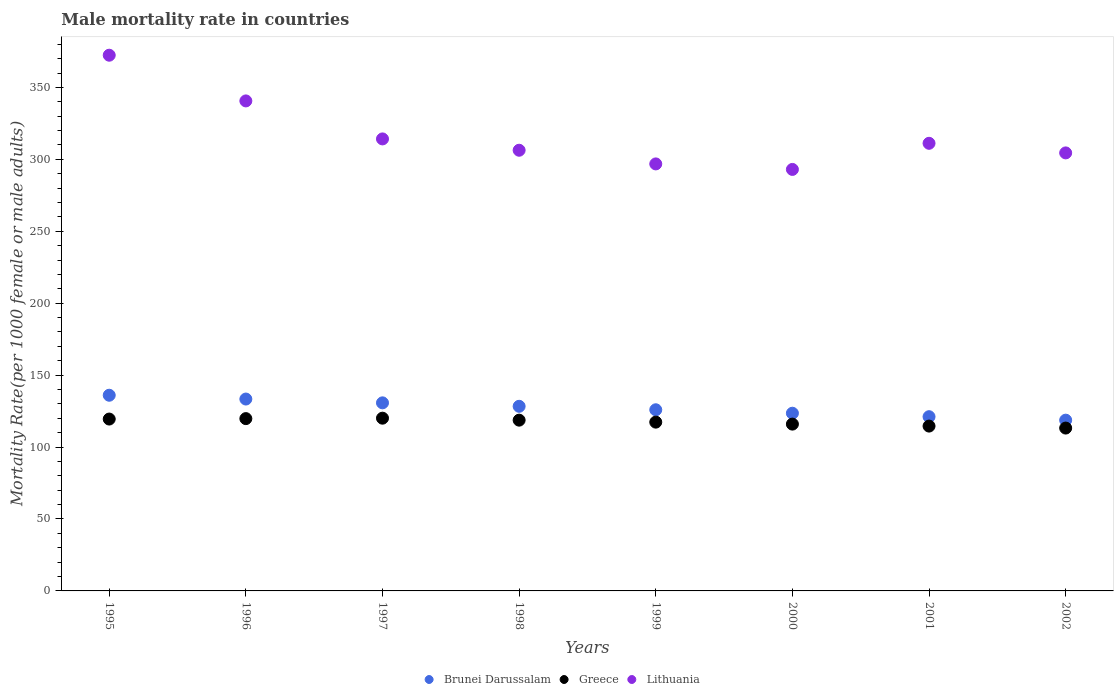What is the male mortality rate in Greece in 2000?
Your answer should be very brief. 115.96. Across all years, what is the maximum male mortality rate in Greece?
Offer a terse response. 120.08. Across all years, what is the minimum male mortality rate in Brunei Darussalam?
Your response must be concise. 118.7. In which year was the male mortality rate in Lithuania maximum?
Offer a terse response. 1995. In which year was the male mortality rate in Lithuania minimum?
Ensure brevity in your answer.  2000. What is the total male mortality rate in Greece in the graph?
Make the answer very short. 939.11. What is the difference between the male mortality rate in Greece in 1995 and that in 1996?
Give a very brief answer. -0.3. What is the difference between the male mortality rate in Greece in 1999 and the male mortality rate in Lithuania in 2001?
Provide a short and direct response. -193.83. What is the average male mortality rate in Lithuania per year?
Your answer should be compact. 317.37. In the year 1995, what is the difference between the male mortality rate in Greece and male mortality rate in Lithuania?
Offer a terse response. -252.91. In how many years, is the male mortality rate in Lithuania greater than 290?
Make the answer very short. 8. What is the ratio of the male mortality rate in Lithuania in 1997 to that in 2001?
Offer a terse response. 1.01. What is the difference between the highest and the second highest male mortality rate in Brunei Darussalam?
Provide a short and direct response. 2.64. What is the difference between the highest and the lowest male mortality rate in Brunei Darussalam?
Your answer should be compact. 17.32. In how many years, is the male mortality rate in Greece greater than the average male mortality rate in Greece taken over all years?
Provide a short and direct response. 4. Is the sum of the male mortality rate in Greece in 1998 and 2002 greater than the maximum male mortality rate in Lithuania across all years?
Provide a short and direct response. No. Is it the case that in every year, the sum of the male mortality rate in Brunei Darussalam and male mortality rate in Lithuania  is greater than the male mortality rate in Greece?
Your answer should be compact. Yes. Does the male mortality rate in Lithuania monotonically increase over the years?
Your response must be concise. No. Is the male mortality rate in Lithuania strictly less than the male mortality rate in Brunei Darussalam over the years?
Ensure brevity in your answer.  No. How many dotlines are there?
Offer a very short reply. 3. How many years are there in the graph?
Offer a terse response. 8. Are the values on the major ticks of Y-axis written in scientific E-notation?
Ensure brevity in your answer.  No. Does the graph contain grids?
Offer a very short reply. No. Where does the legend appear in the graph?
Your answer should be very brief. Bottom center. How many legend labels are there?
Offer a very short reply. 3. What is the title of the graph?
Provide a succinct answer. Male mortality rate in countries. Does "Latin America(all income levels)" appear as one of the legend labels in the graph?
Your answer should be compact. No. What is the label or title of the X-axis?
Offer a terse response. Years. What is the label or title of the Y-axis?
Offer a very short reply. Mortality Rate(per 1000 female or male adults). What is the Mortality Rate(per 1000 female or male adults) of Brunei Darussalam in 1995?
Ensure brevity in your answer.  136.02. What is the Mortality Rate(per 1000 female or male adults) of Greece in 1995?
Provide a succinct answer. 119.47. What is the Mortality Rate(per 1000 female or male adults) of Lithuania in 1995?
Provide a succinct answer. 372.39. What is the Mortality Rate(per 1000 female or male adults) of Brunei Darussalam in 1996?
Offer a terse response. 133.38. What is the Mortality Rate(per 1000 female or male adults) of Greece in 1996?
Ensure brevity in your answer.  119.78. What is the Mortality Rate(per 1000 female or male adults) in Lithuania in 1996?
Provide a short and direct response. 340.62. What is the Mortality Rate(per 1000 female or male adults) in Brunei Darussalam in 1997?
Provide a short and direct response. 130.74. What is the Mortality Rate(per 1000 female or male adults) in Greece in 1997?
Make the answer very short. 120.08. What is the Mortality Rate(per 1000 female or male adults) of Lithuania in 1997?
Your answer should be very brief. 314.2. What is the Mortality Rate(per 1000 female or male adults) of Brunei Darussalam in 1998?
Make the answer very short. 128.33. What is the Mortality Rate(per 1000 female or male adults) of Greece in 1998?
Provide a short and direct response. 118.71. What is the Mortality Rate(per 1000 female or male adults) in Lithuania in 1998?
Offer a very short reply. 306.33. What is the Mortality Rate(per 1000 female or male adults) in Brunei Darussalam in 1999?
Offer a very short reply. 125.92. What is the Mortality Rate(per 1000 female or male adults) of Greece in 1999?
Your response must be concise. 117.33. What is the Mortality Rate(per 1000 female or male adults) in Lithuania in 1999?
Offer a very short reply. 296.83. What is the Mortality Rate(per 1000 female or male adults) of Brunei Darussalam in 2000?
Offer a very short reply. 123.52. What is the Mortality Rate(per 1000 female or male adults) of Greece in 2000?
Give a very brief answer. 115.96. What is the Mortality Rate(per 1000 female or male adults) of Lithuania in 2000?
Give a very brief answer. 293. What is the Mortality Rate(per 1000 female or male adults) in Brunei Darussalam in 2001?
Provide a short and direct response. 121.11. What is the Mortality Rate(per 1000 female or male adults) of Greece in 2001?
Offer a very short reply. 114.58. What is the Mortality Rate(per 1000 female or male adults) in Lithuania in 2001?
Make the answer very short. 311.16. What is the Mortality Rate(per 1000 female or male adults) in Brunei Darussalam in 2002?
Provide a succinct answer. 118.7. What is the Mortality Rate(per 1000 female or male adults) of Greece in 2002?
Give a very brief answer. 113.2. What is the Mortality Rate(per 1000 female or male adults) in Lithuania in 2002?
Your answer should be very brief. 304.48. Across all years, what is the maximum Mortality Rate(per 1000 female or male adults) in Brunei Darussalam?
Make the answer very short. 136.02. Across all years, what is the maximum Mortality Rate(per 1000 female or male adults) of Greece?
Your answer should be compact. 120.08. Across all years, what is the maximum Mortality Rate(per 1000 female or male adults) of Lithuania?
Your answer should be compact. 372.39. Across all years, what is the minimum Mortality Rate(per 1000 female or male adults) of Brunei Darussalam?
Keep it short and to the point. 118.7. Across all years, what is the minimum Mortality Rate(per 1000 female or male adults) of Greece?
Keep it short and to the point. 113.2. Across all years, what is the minimum Mortality Rate(per 1000 female or male adults) in Lithuania?
Provide a short and direct response. 293. What is the total Mortality Rate(per 1000 female or male adults) in Brunei Darussalam in the graph?
Your answer should be very brief. 1017.73. What is the total Mortality Rate(per 1000 female or male adults) of Greece in the graph?
Your answer should be compact. 939.11. What is the total Mortality Rate(per 1000 female or male adults) in Lithuania in the graph?
Provide a succinct answer. 2539. What is the difference between the Mortality Rate(per 1000 female or male adults) of Brunei Darussalam in 1995 and that in 1996?
Provide a short and direct response. 2.64. What is the difference between the Mortality Rate(per 1000 female or male adults) in Greece in 1995 and that in 1996?
Offer a very short reply. -0.3. What is the difference between the Mortality Rate(per 1000 female or male adults) in Lithuania in 1995 and that in 1996?
Ensure brevity in your answer.  31.77. What is the difference between the Mortality Rate(per 1000 female or male adults) in Brunei Darussalam in 1995 and that in 1997?
Offer a very short reply. 5.28. What is the difference between the Mortality Rate(per 1000 female or male adults) in Greece in 1995 and that in 1997?
Provide a succinct answer. -0.61. What is the difference between the Mortality Rate(per 1000 female or male adults) of Lithuania in 1995 and that in 1997?
Your response must be concise. 58.18. What is the difference between the Mortality Rate(per 1000 female or male adults) of Brunei Darussalam in 1995 and that in 1998?
Ensure brevity in your answer.  7.69. What is the difference between the Mortality Rate(per 1000 female or male adults) of Greece in 1995 and that in 1998?
Your answer should be compact. 0.77. What is the difference between the Mortality Rate(per 1000 female or male adults) of Lithuania in 1995 and that in 1998?
Offer a very short reply. 66.06. What is the difference between the Mortality Rate(per 1000 female or male adults) of Brunei Darussalam in 1995 and that in 1999?
Offer a very short reply. 10.1. What is the difference between the Mortality Rate(per 1000 female or male adults) in Greece in 1995 and that in 1999?
Give a very brief answer. 2.14. What is the difference between the Mortality Rate(per 1000 female or male adults) in Lithuania in 1995 and that in 1999?
Ensure brevity in your answer.  75.56. What is the difference between the Mortality Rate(per 1000 female or male adults) of Brunei Darussalam in 1995 and that in 2000?
Your response must be concise. 12.5. What is the difference between the Mortality Rate(per 1000 female or male adults) in Greece in 1995 and that in 2000?
Offer a very short reply. 3.52. What is the difference between the Mortality Rate(per 1000 female or male adults) of Lithuania in 1995 and that in 2000?
Provide a short and direct response. 79.39. What is the difference between the Mortality Rate(per 1000 female or male adults) of Brunei Darussalam in 1995 and that in 2001?
Ensure brevity in your answer.  14.91. What is the difference between the Mortality Rate(per 1000 female or male adults) of Greece in 1995 and that in 2001?
Offer a very short reply. 4.89. What is the difference between the Mortality Rate(per 1000 female or male adults) of Lithuania in 1995 and that in 2001?
Ensure brevity in your answer.  61.23. What is the difference between the Mortality Rate(per 1000 female or male adults) of Brunei Darussalam in 1995 and that in 2002?
Ensure brevity in your answer.  17.32. What is the difference between the Mortality Rate(per 1000 female or male adults) in Greece in 1995 and that in 2002?
Make the answer very short. 6.27. What is the difference between the Mortality Rate(per 1000 female or male adults) in Lithuania in 1995 and that in 2002?
Your response must be concise. 67.91. What is the difference between the Mortality Rate(per 1000 female or male adults) of Brunei Darussalam in 1996 and that in 1997?
Keep it short and to the point. 2.64. What is the difference between the Mortality Rate(per 1000 female or male adults) in Greece in 1996 and that in 1997?
Provide a short and direct response. -0.3. What is the difference between the Mortality Rate(per 1000 female or male adults) of Lithuania in 1996 and that in 1997?
Give a very brief answer. 26.41. What is the difference between the Mortality Rate(per 1000 female or male adults) of Brunei Darussalam in 1996 and that in 1998?
Provide a short and direct response. 5.05. What is the difference between the Mortality Rate(per 1000 female or male adults) in Greece in 1996 and that in 1998?
Ensure brevity in your answer.  1.07. What is the difference between the Mortality Rate(per 1000 female or male adults) in Lithuania in 1996 and that in 1998?
Your answer should be compact. 34.29. What is the difference between the Mortality Rate(per 1000 female or male adults) in Brunei Darussalam in 1996 and that in 1999?
Keep it short and to the point. 7.46. What is the difference between the Mortality Rate(per 1000 female or male adults) in Greece in 1996 and that in 1999?
Offer a terse response. 2.45. What is the difference between the Mortality Rate(per 1000 female or male adults) in Lithuania in 1996 and that in 1999?
Offer a terse response. 43.79. What is the difference between the Mortality Rate(per 1000 female or male adults) of Brunei Darussalam in 1996 and that in 2000?
Ensure brevity in your answer.  9.86. What is the difference between the Mortality Rate(per 1000 female or male adults) in Greece in 1996 and that in 2000?
Your answer should be compact. 3.82. What is the difference between the Mortality Rate(per 1000 female or male adults) of Lithuania in 1996 and that in 2000?
Offer a terse response. 47.62. What is the difference between the Mortality Rate(per 1000 female or male adults) in Brunei Darussalam in 1996 and that in 2001?
Your answer should be compact. 12.27. What is the difference between the Mortality Rate(per 1000 female or male adults) in Greece in 1996 and that in 2001?
Offer a terse response. 5.2. What is the difference between the Mortality Rate(per 1000 female or male adults) of Lithuania in 1996 and that in 2001?
Keep it short and to the point. 29.46. What is the difference between the Mortality Rate(per 1000 female or male adults) of Brunei Darussalam in 1996 and that in 2002?
Provide a succinct answer. 14.68. What is the difference between the Mortality Rate(per 1000 female or male adults) of Greece in 1996 and that in 2002?
Your answer should be very brief. 6.57. What is the difference between the Mortality Rate(per 1000 female or male adults) in Lithuania in 1996 and that in 2002?
Your response must be concise. 36.14. What is the difference between the Mortality Rate(per 1000 female or male adults) in Brunei Darussalam in 1997 and that in 1998?
Your answer should be compact. 2.41. What is the difference between the Mortality Rate(per 1000 female or male adults) of Greece in 1997 and that in 1998?
Ensure brevity in your answer.  1.38. What is the difference between the Mortality Rate(per 1000 female or male adults) in Lithuania in 1997 and that in 1998?
Offer a terse response. 7.88. What is the difference between the Mortality Rate(per 1000 female or male adults) in Brunei Darussalam in 1997 and that in 1999?
Give a very brief answer. 4.81. What is the difference between the Mortality Rate(per 1000 female or male adults) in Greece in 1997 and that in 1999?
Your response must be concise. 2.75. What is the difference between the Mortality Rate(per 1000 female or male adults) in Lithuania in 1997 and that in 1999?
Ensure brevity in your answer.  17.38. What is the difference between the Mortality Rate(per 1000 female or male adults) in Brunei Darussalam in 1997 and that in 2000?
Give a very brief answer. 7.22. What is the difference between the Mortality Rate(per 1000 female or male adults) of Greece in 1997 and that in 2000?
Your answer should be compact. 4.13. What is the difference between the Mortality Rate(per 1000 female or male adults) in Lithuania in 1997 and that in 2000?
Your response must be concise. 21.21. What is the difference between the Mortality Rate(per 1000 female or male adults) of Brunei Darussalam in 1997 and that in 2001?
Ensure brevity in your answer.  9.63. What is the difference between the Mortality Rate(per 1000 female or male adults) in Greece in 1997 and that in 2001?
Provide a short and direct response. 5.5. What is the difference between the Mortality Rate(per 1000 female or male adults) of Lithuania in 1997 and that in 2001?
Provide a short and direct response. 3.05. What is the difference between the Mortality Rate(per 1000 female or male adults) in Brunei Darussalam in 1997 and that in 2002?
Keep it short and to the point. 12.03. What is the difference between the Mortality Rate(per 1000 female or male adults) of Greece in 1997 and that in 2002?
Provide a succinct answer. 6.88. What is the difference between the Mortality Rate(per 1000 female or male adults) of Lithuania in 1997 and that in 2002?
Your answer should be very brief. 9.72. What is the difference between the Mortality Rate(per 1000 female or male adults) of Brunei Darussalam in 1998 and that in 1999?
Ensure brevity in your answer.  2.41. What is the difference between the Mortality Rate(per 1000 female or male adults) in Greece in 1998 and that in 1999?
Provide a succinct answer. 1.38. What is the difference between the Mortality Rate(per 1000 female or male adults) in Lithuania in 1998 and that in 1999?
Offer a terse response. 9.5. What is the difference between the Mortality Rate(per 1000 female or male adults) in Brunei Darussalam in 1998 and that in 2000?
Your answer should be compact. 4.81. What is the difference between the Mortality Rate(per 1000 female or male adults) in Greece in 1998 and that in 2000?
Your answer should be compact. 2.75. What is the difference between the Mortality Rate(per 1000 female or male adults) of Lithuania in 1998 and that in 2000?
Provide a short and direct response. 13.33. What is the difference between the Mortality Rate(per 1000 female or male adults) in Brunei Darussalam in 1998 and that in 2001?
Ensure brevity in your answer.  7.22. What is the difference between the Mortality Rate(per 1000 female or male adults) of Greece in 1998 and that in 2001?
Your answer should be compact. 4.13. What is the difference between the Mortality Rate(per 1000 female or male adults) in Lithuania in 1998 and that in 2001?
Give a very brief answer. -4.83. What is the difference between the Mortality Rate(per 1000 female or male adults) in Brunei Darussalam in 1998 and that in 2002?
Keep it short and to the point. 9.63. What is the difference between the Mortality Rate(per 1000 female or male adults) of Greece in 1998 and that in 2002?
Give a very brief answer. 5.5. What is the difference between the Mortality Rate(per 1000 female or male adults) in Lithuania in 1998 and that in 2002?
Offer a very short reply. 1.85. What is the difference between the Mortality Rate(per 1000 female or male adults) of Brunei Darussalam in 1999 and that in 2000?
Keep it short and to the point. 2.41. What is the difference between the Mortality Rate(per 1000 female or male adults) of Greece in 1999 and that in 2000?
Ensure brevity in your answer.  1.38. What is the difference between the Mortality Rate(per 1000 female or male adults) in Lithuania in 1999 and that in 2000?
Your answer should be compact. 3.83. What is the difference between the Mortality Rate(per 1000 female or male adults) of Brunei Darussalam in 1999 and that in 2001?
Your answer should be very brief. 4.81. What is the difference between the Mortality Rate(per 1000 female or male adults) of Greece in 1999 and that in 2001?
Ensure brevity in your answer.  2.75. What is the difference between the Mortality Rate(per 1000 female or male adults) in Lithuania in 1999 and that in 2001?
Provide a succinct answer. -14.33. What is the difference between the Mortality Rate(per 1000 female or male adults) in Brunei Darussalam in 1999 and that in 2002?
Give a very brief answer. 7.22. What is the difference between the Mortality Rate(per 1000 female or male adults) of Greece in 1999 and that in 2002?
Your response must be concise. 4.13. What is the difference between the Mortality Rate(per 1000 female or male adults) of Lithuania in 1999 and that in 2002?
Give a very brief answer. -7.66. What is the difference between the Mortality Rate(per 1000 female or male adults) in Brunei Darussalam in 2000 and that in 2001?
Your answer should be compact. 2.41. What is the difference between the Mortality Rate(per 1000 female or male adults) in Greece in 2000 and that in 2001?
Provide a succinct answer. 1.38. What is the difference between the Mortality Rate(per 1000 female or male adults) in Lithuania in 2000 and that in 2001?
Your response must be concise. -18.16. What is the difference between the Mortality Rate(per 1000 female or male adults) of Brunei Darussalam in 2000 and that in 2002?
Provide a short and direct response. 4.81. What is the difference between the Mortality Rate(per 1000 female or male adults) of Greece in 2000 and that in 2002?
Give a very brief answer. 2.75. What is the difference between the Mortality Rate(per 1000 female or male adults) of Lithuania in 2000 and that in 2002?
Provide a short and direct response. -11.48. What is the difference between the Mortality Rate(per 1000 female or male adults) of Brunei Darussalam in 2001 and that in 2002?
Provide a succinct answer. 2.41. What is the difference between the Mortality Rate(per 1000 female or male adults) of Greece in 2001 and that in 2002?
Offer a very short reply. 1.38. What is the difference between the Mortality Rate(per 1000 female or male adults) of Lithuania in 2001 and that in 2002?
Your answer should be compact. 6.67. What is the difference between the Mortality Rate(per 1000 female or male adults) in Brunei Darussalam in 1995 and the Mortality Rate(per 1000 female or male adults) in Greece in 1996?
Offer a terse response. 16.24. What is the difference between the Mortality Rate(per 1000 female or male adults) of Brunei Darussalam in 1995 and the Mortality Rate(per 1000 female or male adults) of Lithuania in 1996?
Provide a short and direct response. -204.6. What is the difference between the Mortality Rate(per 1000 female or male adults) of Greece in 1995 and the Mortality Rate(per 1000 female or male adults) of Lithuania in 1996?
Give a very brief answer. -221.15. What is the difference between the Mortality Rate(per 1000 female or male adults) of Brunei Darussalam in 1995 and the Mortality Rate(per 1000 female or male adults) of Greece in 1997?
Make the answer very short. 15.94. What is the difference between the Mortality Rate(per 1000 female or male adults) in Brunei Darussalam in 1995 and the Mortality Rate(per 1000 female or male adults) in Lithuania in 1997?
Keep it short and to the point. -178.18. What is the difference between the Mortality Rate(per 1000 female or male adults) of Greece in 1995 and the Mortality Rate(per 1000 female or male adults) of Lithuania in 1997?
Offer a very short reply. -194.73. What is the difference between the Mortality Rate(per 1000 female or male adults) of Brunei Darussalam in 1995 and the Mortality Rate(per 1000 female or male adults) of Greece in 1998?
Offer a very short reply. 17.32. What is the difference between the Mortality Rate(per 1000 female or male adults) in Brunei Darussalam in 1995 and the Mortality Rate(per 1000 female or male adults) in Lithuania in 1998?
Your answer should be compact. -170.31. What is the difference between the Mortality Rate(per 1000 female or male adults) of Greece in 1995 and the Mortality Rate(per 1000 female or male adults) of Lithuania in 1998?
Your answer should be compact. -186.86. What is the difference between the Mortality Rate(per 1000 female or male adults) of Brunei Darussalam in 1995 and the Mortality Rate(per 1000 female or male adults) of Greece in 1999?
Provide a succinct answer. 18.69. What is the difference between the Mortality Rate(per 1000 female or male adults) in Brunei Darussalam in 1995 and the Mortality Rate(per 1000 female or male adults) in Lithuania in 1999?
Keep it short and to the point. -160.81. What is the difference between the Mortality Rate(per 1000 female or male adults) in Greece in 1995 and the Mortality Rate(per 1000 female or male adults) in Lithuania in 1999?
Offer a very short reply. -177.35. What is the difference between the Mortality Rate(per 1000 female or male adults) in Brunei Darussalam in 1995 and the Mortality Rate(per 1000 female or male adults) in Greece in 2000?
Provide a succinct answer. 20.07. What is the difference between the Mortality Rate(per 1000 female or male adults) in Brunei Darussalam in 1995 and the Mortality Rate(per 1000 female or male adults) in Lithuania in 2000?
Ensure brevity in your answer.  -156.98. What is the difference between the Mortality Rate(per 1000 female or male adults) in Greece in 1995 and the Mortality Rate(per 1000 female or male adults) in Lithuania in 2000?
Give a very brief answer. -173.53. What is the difference between the Mortality Rate(per 1000 female or male adults) of Brunei Darussalam in 1995 and the Mortality Rate(per 1000 female or male adults) of Greece in 2001?
Keep it short and to the point. 21.44. What is the difference between the Mortality Rate(per 1000 female or male adults) in Brunei Darussalam in 1995 and the Mortality Rate(per 1000 female or male adults) in Lithuania in 2001?
Your answer should be compact. -175.13. What is the difference between the Mortality Rate(per 1000 female or male adults) of Greece in 1995 and the Mortality Rate(per 1000 female or male adults) of Lithuania in 2001?
Offer a terse response. -191.68. What is the difference between the Mortality Rate(per 1000 female or male adults) in Brunei Darussalam in 1995 and the Mortality Rate(per 1000 female or male adults) in Greece in 2002?
Your answer should be very brief. 22.82. What is the difference between the Mortality Rate(per 1000 female or male adults) in Brunei Darussalam in 1995 and the Mortality Rate(per 1000 female or male adults) in Lithuania in 2002?
Your answer should be very brief. -168.46. What is the difference between the Mortality Rate(per 1000 female or male adults) of Greece in 1995 and the Mortality Rate(per 1000 female or male adults) of Lithuania in 2002?
Offer a terse response. -185.01. What is the difference between the Mortality Rate(per 1000 female or male adults) of Brunei Darussalam in 1996 and the Mortality Rate(per 1000 female or male adults) of Greece in 1997?
Ensure brevity in your answer.  13.3. What is the difference between the Mortality Rate(per 1000 female or male adults) in Brunei Darussalam in 1996 and the Mortality Rate(per 1000 female or male adults) in Lithuania in 1997?
Ensure brevity in your answer.  -180.82. What is the difference between the Mortality Rate(per 1000 female or male adults) of Greece in 1996 and the Mortality Rate(per 1000 female or male adults) of Lithuania in 1997?
Make the answer very short. -194.43. What is the difference between the Mortality Rate(per 1000 female or male adults) of Brunei Darussalam in 1996 and the Mortality Rate(per 1000 female or male adults) of Greece in 1998?
Make the answer very short. 14.67. What is the difference between the Mortality Rate(per 1000 female or male adults) of Brunei Darussalam in 1996 and the Mortality Rate(per 1000 female or male adults) of Lithuania in 1998?
Your answer should be compact. -172.95. What is the difference between the Mortality Rate(per 1000 female or male adults) in Greece in 1996 and the Mortality Rate(per 1000 female or male adults) in Lithuania in 1998?
Give a very brief answer. -186.55. What is the difference between the Mortality Rate(per 1000 female or male adults) of Brunei Darussalam in 1996 and the Mortality Rate(per 1000 female or male adults) of Greece in 1999?
Give a very brief answer. 16.05. What is the difference between the Mortality Rate(per 1000 female or male adults) in Brunei Darussalam in 1996 and the Mortality Rate(per 1000 female or male adults) in Lithuania in 1999?
Provide a short and direct response. -163.45. What is the difference between the Mortality Rate(per 1000 female or male adults) in Greece in 1996 and the Mortality Rate(per 1000 female or male adults) in Lithuania in 1999?
Give a very brief answer. -177.05. What is the difference between the Mortality Rate(per 1000 female or male adults) in Brunei Darussalam in 1996 and the Mortality Rate(per 1000 female or male adults) in Greece in 2000?
Keep it short and to the point. 17.42. What is the difference between the Mortality Rate(per 1000 female or male adults) of Brunei Darussalam in 1996 and the Mortality Rate(per 1000 female or male adults) of Lithuania in 2000?
Offer a terse response. -159.62. What is the difference between the Mortality Rate(per 1000 female or male adults) of Greece in 1996 and the Mortality Rate(per 1000 female or male adults) of Lithuania in 2000?
Your answer should be compact. -173.22. What is the difference between the Mortality Rate(per 1000 female or male adults) in Brunei Darussalam in 1996 and the Mortality Rate(per 1000 female or male adults) in Greece in 2001?
Keep it short and to the point. 18.8. What is the difference between the Mortality Rate(per 1000 female or male adults) in Brunei Darussalam in 1996 and the Mortality Rate(per 1000 female or male adults) in Lithuania in 2001?
Your response must be concise. -177.78. What is the difference between the Mortality Rate(per 1000 female or male adults) in Greece in 1996 and the Mortality Rate(per 1000 female or male adults) in Lithuania in 2001?
Provide a short and direct response. -191.38. What is the difference between the Mortality Rate(per 1000 female or male adults) in Brunei Darussalam in 1996 and the Mortality Rate(per 1000 female or male adults) in Greece in 2002?
Your response must be concise. 20.18. What is the difference between the Mortality Rate(per 1000 female or male adults) in Brunei Darussalam in 1996 and the Mortality Rate(per 1000 female or male adults) in Lithuania in 2002?
Keep it short and to the point. -171.1. What is the difference between the Mortality Rate(per 1000 female or male adults) in Greece in 1996 and the Mortality Rate(per 1000 female or male adults) in Lithuania in 2002?
Give a very brief answer. -184.7. What is the difference between the Mortality Rate(per 1000 female or male adults) in Brunei Darussalam in 1997 and the Mortality Rate(per 1000 female or male adults) in Greece in 1998?
Offer a terse response. 12.03. What is the difference between the Mortality Rate(per 1000 female or male adults) in Brunei Darussalam in 1997 and the Mortality Rate(per 1000 female or male adults) in Lithuania in 1998?
Offer a very short reply. -175.59. What is the difference between the Mortality Rate(per 1000 female or male adults) in Greece in 1997 and the Mortality Rate(per 1000 female or male adults) in Lithuania in 1998?
Provide a succinct answer. -186.25. What is the difference between the Mortality Rate(per 1000 female or male adults) in Brunei Darussalam in 1997 and the Mortality Rate(per 1000 female or male adults) in Greece in 1999?
Make the answer very short. 13.41. What is the difference between the Mortality Rate(per 1000 female or male adults) in Brunei Darussalam in 1997 and the Mortality Rate(per 1000 female or male adults) in Lithuania in 1999?
Offer a very short reply. -166.09. What is the difference between the Mortality Rate(per 1000 female or male adults) in Greece in 1997 and the Mortality Rate(per 1000 female or male adults) in Lithuania in 1999?
Your answer should be very brief. -176.75. What is the difference between the Mortality Rate(per 1000 female or male adults) in Brunei Darussalam in 1997 and the Mortality Rate(per 1000 female or male adults) in Greece in 2000?
Keep it short and to the point. 14.78. What is the difference between the Mortality Rate(per 1000 female or male adults) of Brunei Darussalam in 1997 and the Mortality Rate(per 1000 female or male adults) of Lithuania in 2000?
Ensure brevity in your answer.  -162.26. What is the difference between the Mortality Rate(per 1000 female or male adults) of Greece in 1997 and the Mortality Rate(per 1000 female or male adults) of Lithuania in 2000?
Give a very brief answer. -172.92. What is the difference between the Mortality Rate(per 1000 female or male adults) in Brunei Darussalam in 1997 and the Mortality Rate(per 1000 female or male adults) in Greece in 2001?
Your answer should be compact. 16.16. What is the difference between the Mortality Rate(per 1000 female or male adults) of Brunei Darussalam in 1997 and the Mortality Rate(per 1000 female or male adults) of Lithuania in 2001?
Ensure brevity in your answer.  -180.42. What is the difference between the Mortality Rate(per 1000 female or male adults) in Greece in 1997 and the Mortality Rate(per 1000 female or male adults) in Lithuania in 2001?
Your response must be concise. -191.07. What is the difference between the Mortality Rate(per 1000 female or male adults) in Brunei Darussalam in 1997 and the Mortality Rate(per 1000 female or male adults) in Greece in 2002?
Make the answer very short. 17.53. What is the difference between the Mortality Rate(per 1000 female or male adults) of Brunei Darussalam in 1997 and the Mortality Rate(per 1000 female or male adults) of Lithuania in 2002?
Make the answer very short. -173.74. What is the difference between the Mortality Rate(per 1000 female or male adults) of Greece in 1997 and the Mortality Rate(per 1000 female or male adults) of Lithuania in 2002?
Your response must be concise. -184.4. What is the difference between the Mortality Rate(per 1000 female or male adults) in Brunei Darussalam in 1998 and the Mortality Rate(per 1000 female or male adults) in Greece in 1999?
Your response must be concise. 11. What is the difference between the Mortality Rate(per 1000 female or male adults) in Brunei Darussalam in 1998 and the Mortality Rate(per 1000 female or male adults) in Lithuania in 1999?
Provide a succinct answer. -168.49. What is the difference between the Mortality Rate(per 1000 female or male adults) in Greece in 1998 and the Mortality Rate(per 1000 female or male adults) in Lithuania in 1999?
Your answer should be compact. -178.12. What is the difference between the Mortality Rate(per 1000 female or male adults) of Brunei Darussalam in 1998 and the Mortality Rate(per 1000 female or male adults) of Greece in 2000?
Your answer should be compact. 12.38. What is the difference between the Mortality Rate(per 1000 female or male adults) of Brunei Darussalam in 1998 and the Mortality Rate(per 1000 female or male adults) of Lithuania in 2000?
Offer a terse response. -164.67. What is the difference between the Mortality Rate(per 1000 female or male adults) of Greece in 1998 and the Mortality Rate(per 1000 female or male adults) of Lithuania in 2000?
Keep it short and to the point. -174.29. What is the difference between the Mortality Rate(per 1000 female or male adults) of Brunei Darussalam in 1998 and the Mortality Rate(per 1000 female or male adults) of Greece in 2001?
Your answer should be compact. 13.75. What is the difference between the Mortality Rate(per 1000 female or male adults) in Brunei Darussalam in 1998 and the Mortality Rate(per 1000 female or male adults) in Lithuania in 2001?
Provide a succinct answer. -182.82. What is the difference between the Mortality Rate(per 1000 female or male adults) of Greece in 1998 and the Mortality Rate(per 1000 female or male adults) of Lithuania in 2001?
Give a very brief answer. -192.45. What is the difference between the Mortality Rate(per 1000 female or male adults) in Brunei Darussalam in 1998 and the Mortality Rate(per 1000 female or male adults) in Greece in 2002?
Make the answer very short. 15.13. What is the difference between the Mortality Rate(per 1000 female or male adults) in Brunei Darussalam in 1998 and the Mortality Rate(per 1000 female or male adults) in Lithuania in 2002?
Give a very brief answer. -176.15. What is the difference between the Mortality Rate(per 1000 female or male adults) in Greece in 1998 and the Mortality Rate(per 1000 female or male adults) in Lithuania in 2002?
Provide a short and direct response. -185.78. What is the difference between the Mortality Rate(per 1000 female or male adults) in Brunei Darussalam in 1999 and the Mortality Rate(per 1000 female or male adults) in Greece in 2000?
Your response must be concise. 9.97. What is the difference between the Mortality Rate(per 1000 female or male adults) of Brunei Darussalam in 1999 and the Mortality Rate(per 1000 female or male adults) of Lithuania in 2000?
Make the answer very short. -167.07. What is the difference between the Mortality Rate(per 1000 female or male adults) of Greece in 1999 and the Mortality Rate(per 1000 female or male adults) of Lithuania in 2000?
Ensure brevity in your answer.  -175.67. What is the difference between the Mortality Rate(per 1000 female or male adults) of Brunei Darussalam in 1999 and the Mortality Rate(per 1000 female or male adults) of Greece in 2001?
Make the answer very short. 11.34. What is the difference between the Mortality Rate(per 1000 female or male adults) in Brunei Darussalam in 1999 and the Mortality Rate(per 1000 female or male adults) in Lithuania in 2001?
Provide a succinct answer. -185.23. What is the difference between the Mortality Rate(per 1000 female or male adults) of Greece in 1999 and the Mortality Rate(per 1000 female or male adults) of Lithuania in 2001?
Offer a very short reply. -193.83. What is the difference between the Mortality Rate(per 1000 female or male adults) of Brunei Darussalam in 1999 and the Mortality Rate(per 1000 female or male adults) of Greece in 2002?
Ensure brevity in your answer.  12.72. What is the difference between the Mortality Rate(per 1000 female or male adults) of Brunei Darussalam in 1999 and the Mortality Rate(per 1000 female or male adults) of Lithuania in 2002?
Your response must be concise. -178.56. What is the difference between the Mortality Rate(per 1000 female or male adults) in Greece in 1999 and the Mortality Rate(per 1000 female or male adults) in Lithuania in 2002?
Offer a terse response. -187.15. What is the difference between the Mortality Rate(per 1000 female or male adults) of Brunei Darussalam in 2000 and the Mortality Rate(per 1000 female or male adults) of Greece in 2001?
Provide a short and direct response. 8.94. What is the difference between the Mortality Rate(per 1000 female or male adults) in Brunei Darussalam in 2000 and the Mortality Rate(per 1000 female or male adults) in Lithuania in 2001?
Your answer should be compact. -187.64. What is the difference between the Mortality Rate(per 1000 female or male adults) in Greece in 2000 and the Mortality Rate(per 1000 female or male adults) in Lithuania in 2001?
Make the answer very short. -195.2. What is the difference between the Mortality Rate(per 1000 female or male adults) of Brunei Darussalam in 2000 and the Mortality Rate(per 1000 female or male adults) of Greece in 2002?
Make the answer very short. 10.31. What is the difference between the Mortality Rate(per 1000 female or male adults) of Brunei Darussalam in 2000 and the Mortality Rate(per 1000 female or male adults) of Lithuania in 2002?
Give a very brief answer. -180.96. What is the difference between the Mortality Rate(per 1000 female or male adults) of Greece in 2000 and the Mortality Rate(per 1000 female or male adults) of Lithuania in 2002?
Provide a short and direct response. -188.53. What is the difference between the Mortality Rate(per 1000 female or male adults) of Brunei Darussalam in 2001 and the Mortality Rate(per 1000 female or male adults) of Greece in 2002?
Give a very brief answer. 7.91. What is the difference between the Mortality Rate(per 1000 female or male adults) in Brunei Darussalam in 2001 and the Mortality Rate(per 1000 female or male adults) in Lithuania in 2002?
Keep it short and to the point. -183.37. What is the difference between the Mortality Rate(per 1000 female or male adults) of Greece in 2001 and the Mortality Rate(per 1000 female or male adults) of Lithuania in 2002?
Provide a succinct answer. -189.9. What is the average Mortality Rate(per 1000 female or male adults) in Brunei Darussalam per year?
Your response must be concise. 127.22. What is the average Mortality Rate(per 1000 female or male adults) of Greece per year?
Keep it short and to the point. 117.39. What is the average Mortality Rate(per 1000 female or male adults) in Lithuania per year?
Keep it short and to the point. 317.37. In the year 1995, what is the difference between the Mortality Rate(per 1000 female or male adults) in Brunei Darussalam and Mortality Rate(per 1000 female or male adults) in Greece?
Your answer should be compact. 16.55. In the year 1995, what is the difference between the Mortality Rate(per 1000 female or male adults) in Brunei Darussalam and Mortality Rate(per 1000 female or male adults) in Lithuania?
Provide a succinct answer. -236.37. In the year 1995, what is the difference between the Mortality Rate(per 1000 female or male adults) in Greece and Mortality Rate(per 1000 female or male adults) in Lithuania?
Keep it short and to the point. -252.91. In the year 1996, what is the difference between the Mortality Rate(per 1000 female or male adults) in Brunei Darussalam and Mortality Rate(per 1000 female or male adults) in Greece?
Ensure brevity in your answer.  13.6. In the year 1996, what is the difference between the Mortality Rate(per 1000 female or male adults) of Brunei Darussalam and Mortality Rate(per 1000 female or male adults) of Lithuania?
Keep it short and to the point. -207.24. In the year 1996, what is the difference between the Mortality Rate(per 1000 female or male adults) in Greece and Mortality Rate(per 1000 female or male adults) in Lithuania?
Keep it short and to the point. -220.84. In the year 1997, what is the difference between the Mortality Rate(per 1000 female or male adults) of Brunei Darussalam and Mortality Rate(per 1000 female or male adults) of Greece?
Your response must be concise. 10.66. In the year 1997, what is the difference between the Mortality Rate(per 1000 female or male adults) of Brunei Darussalam and Mortality Rate(per 1000 female or male adults) of Lithuania?
Your answer should be very brief. -183.47. In the year 1997, what is the difference between the Mortality Rate(per 1000 female or male adults) of Greece and Mortality Rate(per 1000 female or male adults) of Lithuania?
Make the answer very short. -194.12. In the year 1998, what is the difference between the Mortality Rate(per 1000 female or male adults) in Brunei Darussalam and Mortality Rate(per 1000 female or male adults) in Greece?
Offer a terse response. 9.63. In the year 1998, what is the difference between the Mortality Rate(per 1000 female or male adults) in Brunei Darussalam and Mortality Rate(per 1000 female or male adults) in Lithuania?
Your response must be concise. -178. In the year 1998, what is the difference between the Mortality Rate(per 1000 female or male adults) in Greece and Mortality Rate(per 1000 female or male adults) in Lithuania?
Ensure brevity in your answer.  -187.62. In the year 1999, what is the difference between the Mortality Rate(per 1000 female or male adults) in Brunei Darussalam and Mortality Rate(per 1000 female or male adults) in Greece?
Offer a very short reply. 8.59. In the year 1999, what is the difference between the Mortality Rate(per 1000 female or male adults) in Brunei Darussalam and Mortality Rate(per 1000 female or male adults) in Lithuania?
Give a very brief answer. -170.9. In the year 1999, what is the difference between the Mortality Rate(per 1000 female or male adults) of Greece and Mortality Rate(per 1000 female or male adults) of Lithuania?
Provide a succinct answer. -179.5. In the year 2000, what is the difference between the Mortality Rate(per 1000 female or male adults) of Brunei Darussalam and Mortality Rate(per 1000 female or male adults) of Greece?
Offer a very short reply. 7.56. In the year 2000, what is the difference between the Mortality Rate(per 1000 female or male adults) of Brunei Darussalam and Mortality Rate(per 1000 female or male adults) of Lithuania?
Offer a terse response. -169.48. In the year 2000, what is the difference between the Mortality Rate(per 1000 female or male adults) of Greece and Mortality Rate(per 1000 female or male adults) of Lithuania?
Provide a short and direct response. -177.04. In the year 2001, what is the difference between the Mortality Rate(per 1000 female or male adults) of Brunei Darussalam and Mortality Rate(per 1000 female or male adults) of Greece?
Your answer should be compact. 6.53. In the year 2001, what is the difference between the Mortality Rate(per 1000 female or male adults) in Brunei Darussalam and Mortality Rate(per 1000 female or male adults) in Lithuania?
Give a very brief answer. -190.04. In the year 2001, what is the difference between the Mortality Rate(per 1000 female or male adults) in Greece and Mortality Rate(per 1000 female or male adults) in Lithuania?
Make the answer very short. -196.58. In the year 2002, what is the difference between the Mortality Rate(per 1000 female or male adults) in Brunei Darussalam and Mortality Rate(per 1000 female or male adults) in Greece?
Keep it short and to the point. 5.5. In the year 2002, what is the difference between the Mortality Rate(per 1000 female or male adults) of Brunei Darussalam and Mortality Rate(per 1000 female or male adults) of Lithuania?
Your answer should be very brief. -185.78. In the year 2002, what is the difference between the Mortality Rate(per 1000 female or male adults) in Greece and Mortality Rate(per 1000 female or male adults) in Lithuania?
Give a very brief answer. -191.28. What is the ratio of the Mortality Rate(per 1000 female or male adults) in Brunei Darussalam in 1995 to that in 1996?
Your answer should be compact. 1.02. What is the ratio of the Mortality Rate(per 1000 female or male adults) in Lithuania in 1995 to that in 1996?
Your answer should be very brief. 1.09. What is the ratio of the Mortality Rate(per 1000 female or male adults) of Brunei Darussalam in 1995 to that in 1997?
Your answer should be very brief. 1.04. What is the ratio of the Mortality Rate(per 1000 female or male adults) of Lithuania in 1995 to that in 1997?
Offer a terse response. 1.19. What is the ratio of the Mortality Rate(per 1000 female or male adults) in Brunei Darussalam in 1995 to that in 1998?
Ensure brevity in your answer.  1.06. What is the ratio of the Mortality Rate(per 1000 female or male adults) in Greece in 1995 to that in 1998?
Keep it short and to the point. 1.01. What is the ratio of the Mortality Rate(per 1000 female or male adults) of Lithuania in 1995 to that in 1998?
Give a very brief answer. 1.22. What is the ratio of the Mortality Rate(per 1000 female or male adults) of Brunei Darussalam in 1995 to that in 1999?
Offer a terse response. 1.08. What is the ratio of the Mortality Rate(per 1000 female or male adults) of Greece in 1995 to that in 1999?
Provide a short and direct response. 1.02. What is the ratio of the Mortality Rate(per 1000 female or male adults) in Lithuania in 1995 to that in 1999?
Your answer should be compact. 1.25. What is the ratio of the Mortality Rate(per 1000 female or male adults) in Brunei Darussalam in 1995 to that in 2000?
Make the answer very short. 1.1. What is the ratio of the Mortality Rate(per 1000 female or male adults) of Greece in 1995 to that in 2000?
Make the answer very short. 1.03. What is the ratio of the Mortality Rate(per 1000 female or male adults) of Lithuania in 1995 to that in 2000?
Your answer should be very brief. 1.27. What is the ratio of the Mortality Rate(per 1000 female or male adults) of Brunei Darussalam in 1995 to that in 2001?
Your answer should be compact. 1.12. What is the ratio of the Mortality Rate(per 1000 female or male adults) in Greece in 1995 to that in 2001?
Keep it short and to the point. 1.04. What is the ratio of the Mortality Rate(per 1000 female or male adults) of Lithuania in 1995 to that in 2001?
Ensure brevity in your answer.  1.2. What is the ratio of the Mortality Rate(per 1000 female or male adults) in Brunei Darussalam in 1995 to that in 2002?
Ensure brevity in your answer.  1.15. What is the ratio of the Mortality Rate(per 1000 female or male adults) of Greece in 1995 to that in 2002?
Offer a terse response. 1.06. What is the ratio of the Mortality Rate(per 1000 female or male adults) of Lithuania in 1995 to that in 2002?
Give a very brief answer. 1.22. What is the ratio of the Mortality Rate(per 1000 female or male adults) of Brunei Darussalam in 1996 to that in 1997?
Keep it short and to the point. 1.02. What is the ratio of the Mortality Rate(per 1000 female or male adults) of Lithuania in 1996 to that in 1997?
Offer a terse response. 1.08. What is the ratio of the Mortality Rate(per 1000 female or male adults) in Brunei Darussalam in 1996 to that in 1998?
Make the answer very short. 1.04. What is the ratio of the Mortality Rate(per 1000 female or male adults) of Lithuania in 1996 to that in 1998?
Your answer should be compact. 1.11. What is the ratio of the Mortality Rate(per 1000 female or male adults) in Brunei Darussalam in 1996 to that in 1999?
Ensure brevity in your answer.  1.06. What is the ratio of the Mortality Rate(per 1000 female or male adults) in Greece in 1996 to that in 1999?
Make the answer very short. 1.02. What is the ratio of the Mortality Rate(per 1000 female or male adults) in Lithuania in 1996 to that in 1999?
Keep it short and to the point. 1.15. What is the ratio of the Mortality Rate(per 1000 female or male adults) of Brunei Darussalam in 1996 to that in 2000?
Offer a very short reply. 1.08. What is the ratio of the Mortality Rate(per 1000 female or male adults) of Greece in 1996 to that in 2000?
Provide a short and direct response. 1.03. What is the ratio of the Mortality Rate(per 1000 female or male adults) of Lithuania in 1996 to that in 2000?
Make the answer very short. 1.16. What is the ratio of the Mortality Rate(per 1000 female or male adults) of Brunei Darussalam in 1996 to that in 2001?
Your answer should be very brief. 1.1. What is the ratio of the Mortality Rate(per 1000 female or male adults) of Greece in 1996 to that in 2001?
Your answer should be compact. 1.05. What is the ratio of the Mortality Rate(per 1000 female or male adults) of Lithuania in 1996 to that in 2001?
Your response must be concise. 1.09. What is the ratio of the Mortality Rate(per 1000 female or male adults) in Brunei Darussalam in 1996 to that in 2002?
Give a very brief answer. 1.12. What is the ratio of the Mortality Rate(per 1000 female or male adults) of Greece in 1996 to that in 2002?
Your answer should be compact. 1.06. What is the ratio of the Mortality Rate(per 1000 female or male adults) of Lithuania in 1996 to that in 2002?
Provide a succinct answer. 1.12. What is the ratio of the Mortality Rate(per 1000 female or male adults) in Brunei Darussalam in 1997 to that in 1998?
Your answer should be very brief. 1.02. What is the ratio of the Mortality Rate(per 1000 female or male adults) in Greece in 1997 to that in 1998?
Make the answer very short. 1.01. What is the ratio of the Mortality Rate(per 1000 female or male adults) in Lithuania in 1997 to that in 1998?
Your answer should be compact. 1.03. What is the ratio of the Mortality Rate(per 1000 female or male adults) in Brunei Darussalam in 1997 to that in 1999?
Ensure brevity in your answer.  1.04. What is the ratio of the Mortality Rate(per 1000 female or male adults) in Greece in 1997 to that in 1999?
Give a very brief answer. 1.02. What is the ratio of the Mortality Rate(per 1000 female or male adults) in Lithuania in 1997 to that in 1999?
Your answer should be very brief. 1.06. What is the ratio of the Mortality Rate(per 1000 female or male adults) in Brunei Darussalam in 1997 to that in 2000?
Your answer should be very brief. 1.06. What is the ratio of the Mortality Rate(per 1000 female or male adults) in Greece in 1997 to that in 2000?
Offer a very short reply. 1.04. What is the ratio of the Mortality Rate(per 1000 female or male adults) of Lithuania in 1997 to that in 2000?
Provide a succinct answer. 1.07. What is the ratio of the Mortality Rate(per 1000 female or male adults) in Brunei Darussalam in 1997 to that in 2001?
Offer a very short reply. 1.08. What is the ratio of the Mortality Rate(per 1000 female or male adults) in Greece in 1997 to that in 2001?
Your response must be concise. 1.05. What is the ratio of the Mortality Rate(per 1000 female or male adults) in Lithuania in 1997 to that in 2001?
Ensure brevity in your answer.  1.01. What is the ratio of the Mortality Rate(per 1000 female or male adults) of Brunei Darussalam in 1997 to that in 2002?
Your response must be concise. 1.1. What is the ratio of the Mortality Rate(per 1000 female or male adults) of Greece in 1997 to that in 2002?
Ensure brevity in your answer.  1.06. What is the ratio of the Mortality Rate(per 1000 female or male adults) in Lithuania in 1997 to that in 2002?
Your response must be concise. 1.03. What is the ratio of the Mortality Rate(per 1000 female or male adults) of Brunei Darussalam in 1998 to that in 1999?
Keep it short and to the point. 1.02. What is the ratio of the Mortality Rate(per 1000 female or male adults) of Greece in 1998 to that in 1999?
Provide a succinct answer. 1.01. What is the ratio of the Mortality Rate(per 1000 female or male adults) in Lithuania in 1998 to that in 1999?
Offer a terse response. 1.03. What is the ratio of the Mortality Rate(per 1000 female or male adults) in Brunei Darussalam in 1998 to that in 2000?
Give a very brief answer. 1.04. What is the ratio of the Mortality Rate(per 1000 female or male adults) in Greece in 1998 to that in 2000?
Make the answer very short. 1.02. What is the ratio of the Mortality Rate(per 1000 female or male adults) in Lithuania in 1998 to that in 2000?
Offer a very short reply. 1.05. What is the ratio of the Mortality Rate(per 1000 female or male adults) of Brunei Darussalam in 1998 to that in 2001?
Ensure brevity in your answer.  1.06. What is the ratio of the Mortality Rate(per 1000 female or male adults) of Greece in 1998 to that in 2001?
Your answer should be very brief. 1.04. What is the ratio of the Mortality Rate(per 1000 female or male adults) in Lithuania in 1998 to that in 2001?
Make the answer very short. 0.98. What is the ratio of the Mortality Rate(per 1000 female or male adults) in Brunei Darussalam in 1998 to that in 2002?
Make the answer very short. 1.08. What is the ratio of the Mortality Rate(per 1000 female or male adults) of Greece in 1998 to that in 2002?
Provide a short and direct response. 1.05. What is the ratio of the Mortality Rate(per 1000 female or male adults) in Lithuania in 1998 to that in 2002?
Provide a succinct answer. 1.01. What is the ratio of the Mortality Rate(per 1000 female or male adults) of Brunei Darussalam in 1999 to that in 2000?
Ensure brevity in your answer.  1.02. What is the ratio of the Mortality Rate(per 1000 female or male adults) in Greece in 1999 to that in 2000?
Give a very brief answer. 1.01. What is the ratio of the Mortality Rate(per 1000 female or male adults) in Lithuania in 1999 to that in 2000?
Keep it short and to the point. 1.01. What is the ratio of the Mortality Rate(per 1000 female or male adults) in Brunei Darussalam in 1999 to that in 2001?
Provide a short and direct response. 1.04. What is the ratio of the Mortality Rate(per 1000 female or male adults) of Greece in 1999 to that in 2001?
Offer a terse response. 1.02. What is the ratio of the Mortality Rate(per 1000 female or male adults) of Lithuania in 1999 to that in 2001?
Offer a terse response. 0.95. What is the ratio of the Mortality Rate(per 1000 female or male adults) in Brunei Darussalam in 1999 to that in 2002?
Your answer should be compact. 1.06. What is the ratio of the Mortality Rate(per 1000 female or male adults) in Greece in 1999 to that in 2002?
Keep it short and to the point. 1.04. What is the ratio of the Mortality Rate(per 1000 female or male adults) in Lithuania in 1999 to that in 2002?
Offer a very short reply. 0.97. What is the ratio of the Mortality Rate(per 1000 female or male adults) in Brunei Darussalam in 2000 to that in 2001?
Offer a terse response. 1.02. What is the ratio of the Mortality Rate(per 1000 female or male adults) in Greece in 2000 to that in 2001?
Provide a succinct answer. 1.01. What is the ratio of the Mortality Rate(per 1000 female or male adults) in Lithuania in 2000 to that in 2001?
Provide a short and direct response. 0.94. What is the ratio of the Mortality Rate(per 1000 female or male adults) in Brunei Darussalam in 2000 to that in 2002?
Your answer should be very brief. 1.04. What is the ratio of the Mortality Rate(per 1000 female or male adults) of Greece in 2000 to that in 2002?
Your response must be concise. 1.02. What is the ratio of the Mortality Rate(per 1000 female or male adults) in Lithuania in 2000 to that in 2002?
Provide a succinct answer. 0.96. What is the ratio of the Mortality Rate(per 1000 female or male adults) in Brunei Darussalam in 2001 to that in 2002?
Provide a short and direct response. 1.02. What is the ratio of the Mortality Rate(per 1000 female or male adults) of Greece in 2001 to that in 2002?
Offer a terse response. 1.01. What is the ratio of the Mortality Rate(per 1000 female or male adults) of Lithuania in 2001 to that in 2002?
Provide a succinct answer. 1.02. What is the difference between the highest and the second highest Mortality Rate(per 1000 female or male adults) in Brunei Darussalam?
Give a very brief answer. 2.64. What is the difference between the highest and the second highest Mortality Rate(per 1000 female or male adults) of Greece?
Ensure brevity in your answer.  0.3. What is the difference between the highest and the second highest Mortality Rate(per 1000 female or male adults) in Lithuania?
Ensure brevity in your answer.  31.77. What is the difference between the highest and the lowest Mortality Rate(per 1000 female or male adults) in Brunei Darussalam?
Ensure brevity in your answer.  17.32. What is the difference between the highest and the lowest Mortality Rate(per 1000 female or male adults) of Greece?
Keep it short and to the point. 6.88. What is the difference between the highest and the lowest Mortality Rate(per 1000 female or male adults) in Lithuania?
Ensure brevity in your answer.  79.39. 